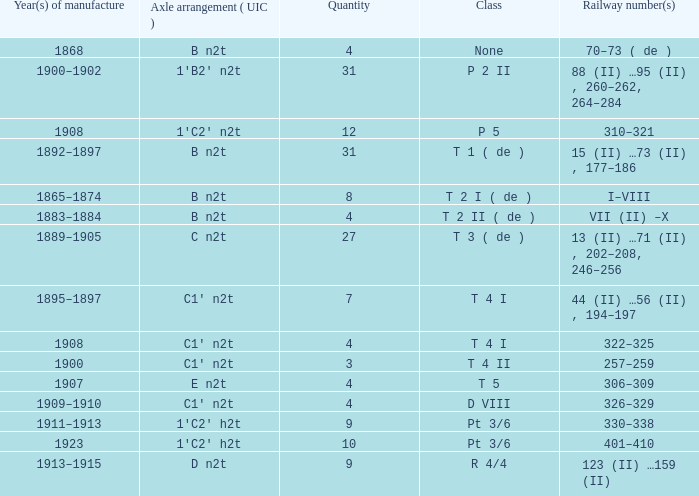Could you parse the entire table? {'header': ['Year(s) of manufacture', 'Axle arrangement ( UIC )', 'Quantity', 'Class', 'Railway number(s)'], 'rows': [['1868', 'B n2t', '4', 'None', '70–73 ( de )'], ['1900–1902', '1′B2′ n2t', '31', 'P 2 II', '88 (II) …95 (II) , 260–262, 264–284'], ['1908', '1′C2′ n2t', '12', 'P 5', '310–321'], ['1892–1897', 'B n2t', '31', 'T 1 ( de )', '15 (II) …73 (II) , 177–186'], ['1865–1874', 'B n2t', '8', 'T 2 I ( de )', 'I–VIII'], ['1883–1884', 'B n2t', '4', 'T 2 II ( de )', 'VII (II) –X'], ['1889–1905', 'C n2t', '27', 'T 3 ( de )', '13 (II) …71 (II) , 202–208, 246–256'], ['1895–1897', 'C1′ n2t', '7', 'T 4 I', '44 (II) …56 (II) , 194–197'], ['1908', 'C1′ n2t', '4', 'T 4 I', '322–325'], ['1900', 'C1′ n2t', '3', 'T 4 II', '257–259'], ['1907', 'E n2t', '4', 'T 5', '306–309'], ['1909–1910', 'C1′ n2t', '4', 'D VIII', '326–329'], ['1911–1913', '1′C2′ h2t', '9', 'Pt 3/6', '330–338'], ['1923', '1′C2′ h2t', '10', 'Pt 3/6', '401–410'], ['1913–1915', 'D n2t', '9', 'R 4/4', '123 (II) …159 (II)']]} What year was the b n2t axle arrangement, which has a quantity of 31, manufactured? 1892–1897. 